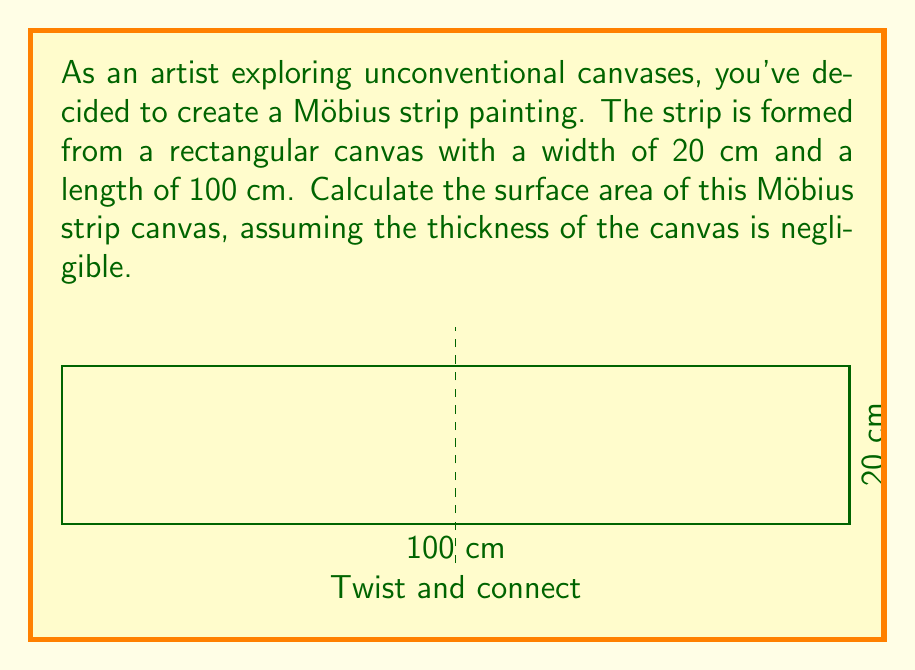Give your solution to this math problem. Let's approach this step-by-step:

1) First, recall that a Möbius strip is created by taking a rectangular strip and giving it a half-twist before connecting the ends.

2) The surface area of a Möbius strip is equal to the area of one side of the original rectangle. This is because the twist creates a surface with only one side.

3) The area of a rectangle is given by the formula:

   $$A = l \times w$$

   where $A$ is the area, $l$ is the length, and $w$ is the width.

4) In this case:
   $l = 100$ cm
   $w = 20$ cm

5) Substituting these values into the formula:

   $$A = 100 \text{ cm} \times 20 \text{ cm} = 2000 \text{ cm}^2$$

6) Therefore, the surface area of the Möbius strip canvas is 2000 square centimeters.

Note: This calculation assumes the canvas has negligible thickness. In reality, a canvas would have some thickness, which would add a small amount to the total surface area, but this is typically ignored in mathematical calculations of Möbius strips.
Answer: $2000 \text{ cm}^2$ 